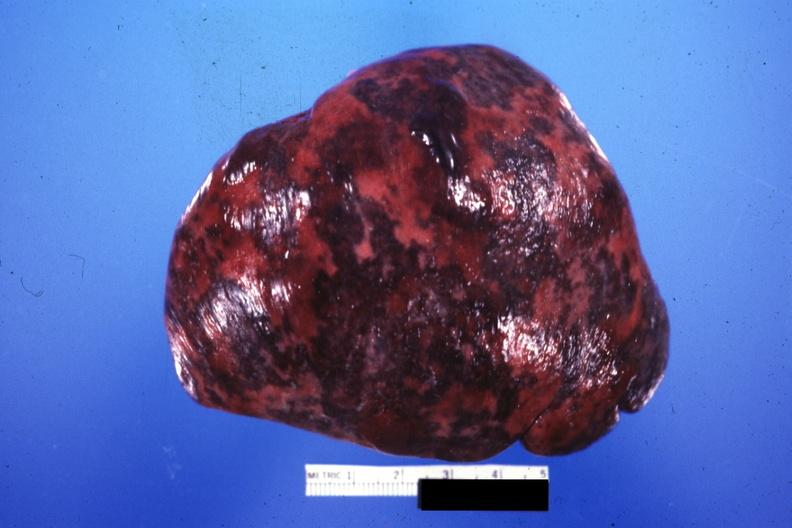s spleen present?
Answer the question using a single word or phrase. Yes 